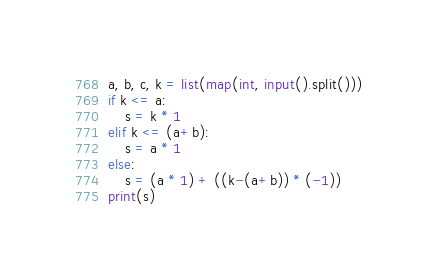<code> <loc_0><loc_0><loc_500><loc_500><_Python_>a, b, c, k = list(map(int, input().split()))
if k <= a:
	s = k * 1
elif k <= (a+b):
	s = a * 1
else:
	s = (a * 1) + ((k-(a+b)) * (-1))
print(s) </code> 